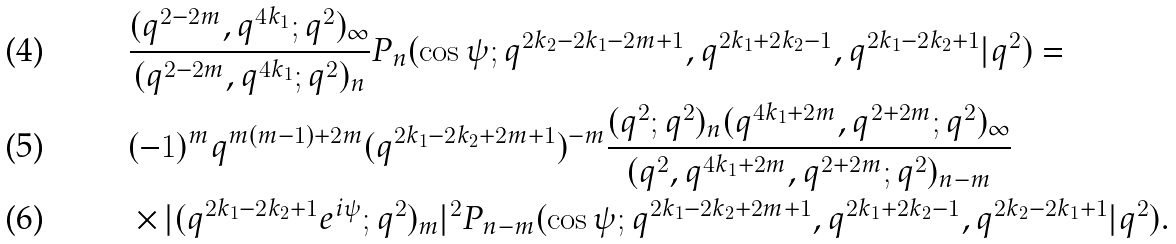<formula> <loc_0><loc_0><loc_500><loc_500>& \frac { ( q ^ { 2 - 2 m } , q ^ { 4 k _ { 1 } } ; q ^ { 2 } ) _ { \infty } } { ( q ^ { 2 - 2 m } , q ^ { 4 k _ { 1 } } ; q ^ { 2 } ) _ { n } } P _ { n } ( \cos \psi ; q ^ { 2 k _ { 2 } - 2 k _ { 1 } - 2 m + 1 } , q ^ { 2 k _ { 1 } + 2 k _ { 2 } - 1 } , q ^ { 2 k _ { 1 } - 2 k _ { 2 } + 1 } | q ^ { 2 } ) = \\ & ( - 1 ) ^ { m } q ^ { m ( m - 1 ) + 2 m } ( q ^ { 2 k _ { 1 } - 2 k _ { 2 } + 2 m + 1 } ) ^ { - m } \frac { ( q ^ { 2 } ; q ^ { 2 } ) _ { n } ( q ^ { 4 k _ { 1 } + 2 m } , q ^ { 2 + 2 m } ; q ^ { 2 } ) _ { \infty } } { ( q ^ { 2 } , q ^ { 4 k _ { 1 } + 2 m } , q ^ { 2 + 2 m } ; q ^ { 2 } ) _ { n - m } } \\ & \times | ( q ^ { 2 k _ { 1 } - 2 k _ { 2 } + 1 } e ^ { i \psi } ; q ^ { 2 } ) _ { m } | ^ { 2 } P _ { n - m } ( \cos \psi ; q ^ { 2 k _ { 1 } - 2 k _ { 2 } + 2 m + 1 } , q ^ { 2 k _ { 1 } + 2 k _ { 2 } - 1 } , q ^ { 2 k _ { 2 } - 2 k _ { 1 } + 1 } | q ^ { 2 } ) .</formula> 